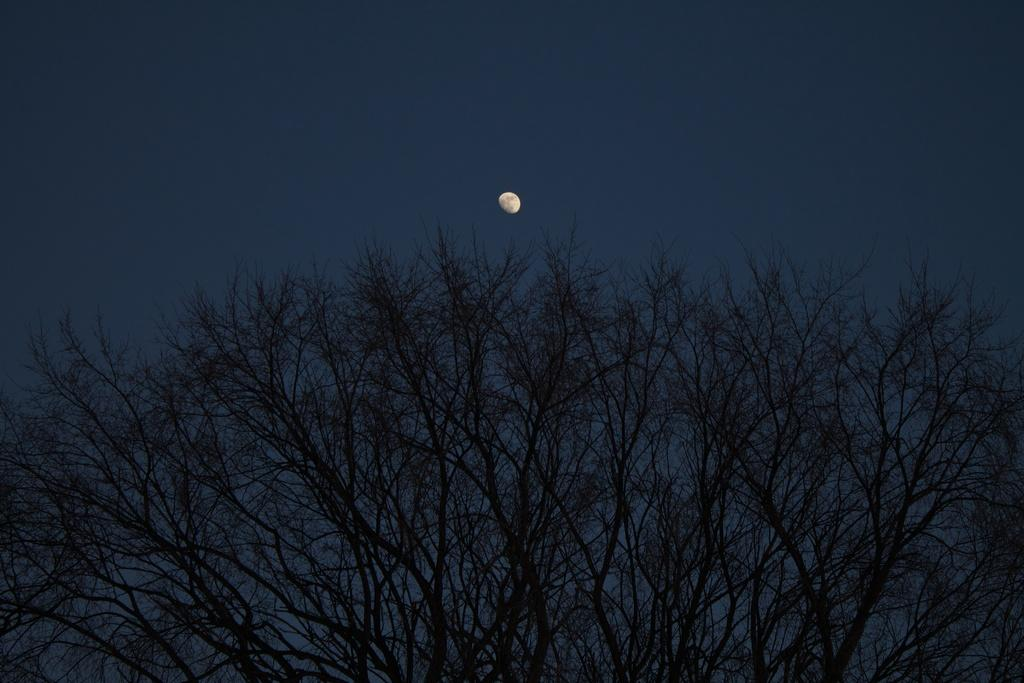What is located at the bottom of the image? There is a tree at the bottom of the image. What can be seen in the background of the image? The sky is visible in the background of the image. What celestial body is present at the top of the image? The moon is present at the top of the image. What type of wool is being spun by the grandmother in the image? There is no grandmother or wool present in the image; it only features a tree, the sky, and the moon. How many flies can be seen buzzing around the tree in the image? There are no flies present in the image; it only features a tree, the sky, and the moon. 